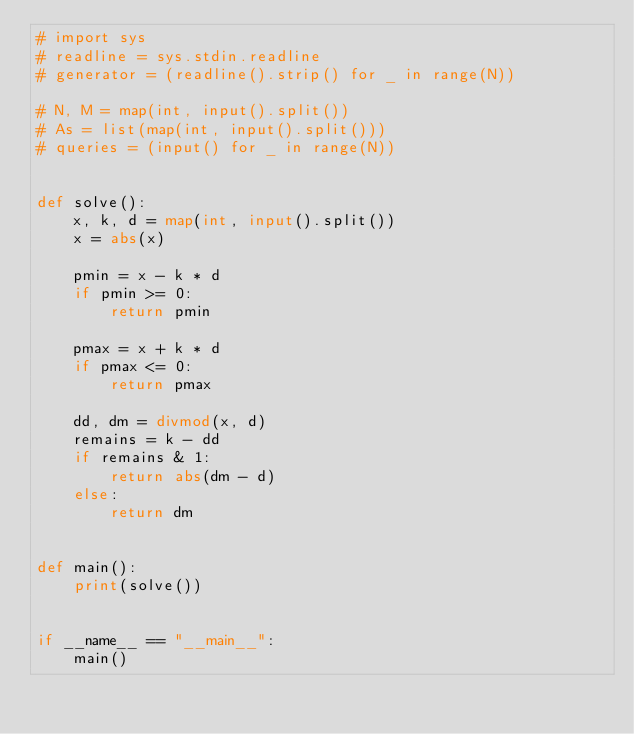Convert code to text. <code><loc_0><loc_0><loc_500><loc_500><_Python_># import sys
# readline = sys.stdin.readline
# generator = (readline().strip() for _ in range(N))

# N, M = map(int, input().split())
# As = list(map(int, input().split()))
# queries = (input() for _ in range(N))


def solve():
    x, k, d = map(int, input().split())
    x = abs(x)

    pmin = x - k * d
    if pmin >= 0:
        return pmin

    pmax = x + k * d
    if pmax <= 0:
        return pmax

    dd, dm = divmod(x, d)
    remains = k - dd
    if remains & 1:
        return abs(dm - d)
    else:
        return dm


def main():
    print(solve())


if __name__ == "__main__":
    main()
</code> 